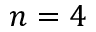Convert formula to latex. <formula><loc_0><loc_0><loc_500><loc_500>n = 4</formula> 